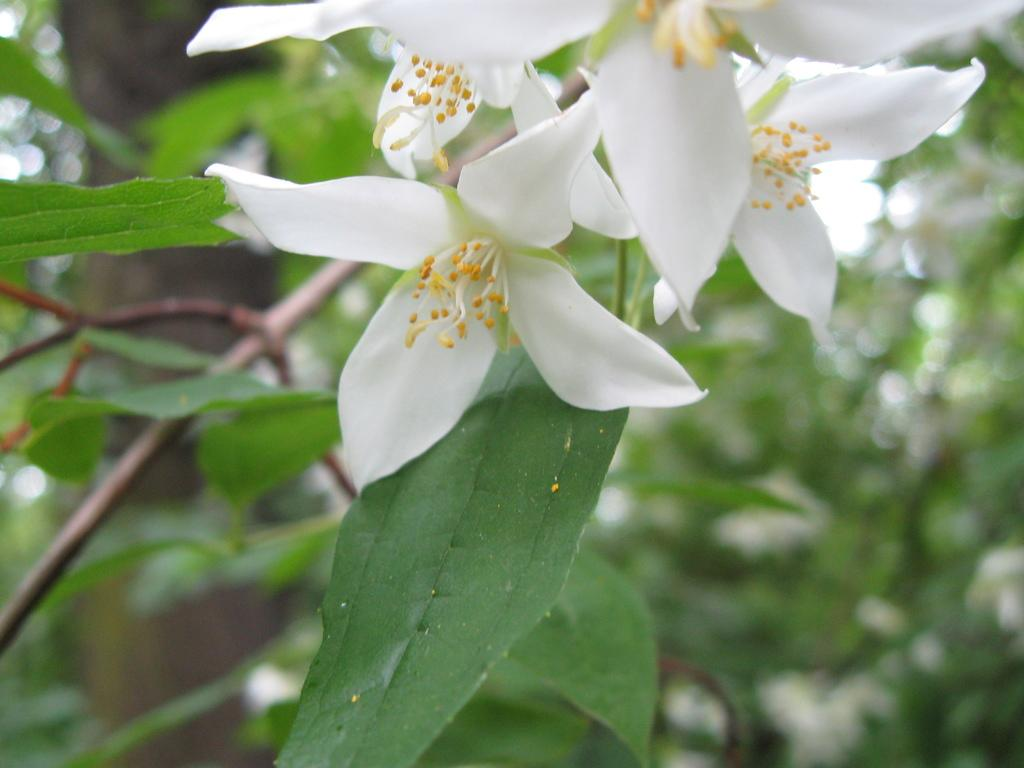What type of flowers can be seen in the image? There are white flowers in the image. What else is present in the image besides the flowers? There are leaves in the image. Can you describe the background of the image? The background of the image is blurred. How many boys are present in the image? There are no boys present in the image; it features white flowers and leaves. What type of relation do the flowers have with the leaves in the image? The flowers and leaves are separate elements in the image and do not have a direct relation. 